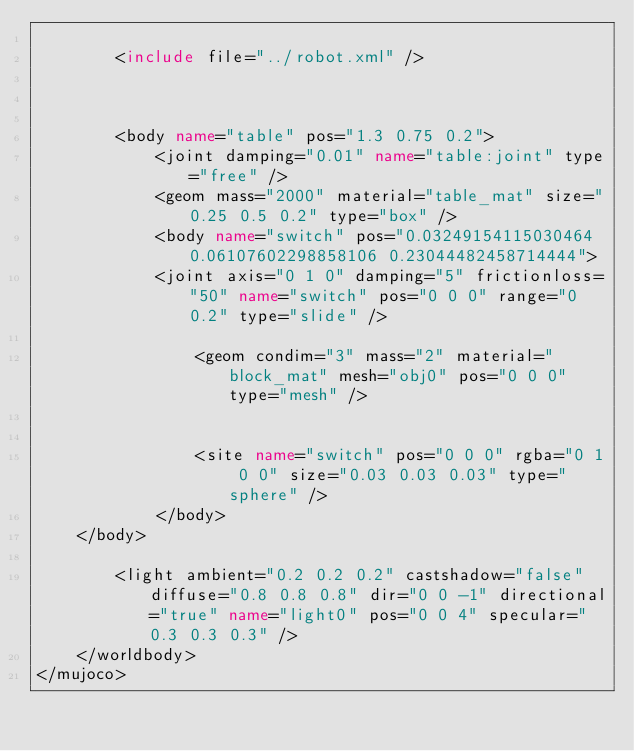Convert code to text. <code><loc_0><loc_0><loc_500><loc_500><_XML_>
		<include file="../robot.xml" />

		

		<body name="table" pos="1.3 0.75 0.2">
			<joint damping="0.01" name="table:joint" type="free" />
			<geom mass="2000" material="table_mat" size="0.25 0.5 0.2" type="box" />
			<body name="switch" pos="0.03249154115030464 0.06107602298858106 0.23044482458714444">
		    <joint axis="0 1 0" damping="5" frictionloss="50" name="switch" pos="0 0 0" range="0 0.2" type="slide" />
				
				<geom condim="3" mass="2" material="block_mat" mesh="obj0" pos="0 0 0" type="mesh" />
				
				
				<site name="switch" pos="0 0 0" rgba="0 1 0 0" size="0.03 0.03 0.03" type="sphere" />
			</body>
    </body>

		<light ambient="0.2 0.2 0.2" castshadow="false" diffuse="0.8 0.8 0.8" dir="0 0 -1" directional="true" name="light0" pos="0 0 4" specular="0.3 0.3 0.3" />
	</worldbody>
</mujoco></code> 